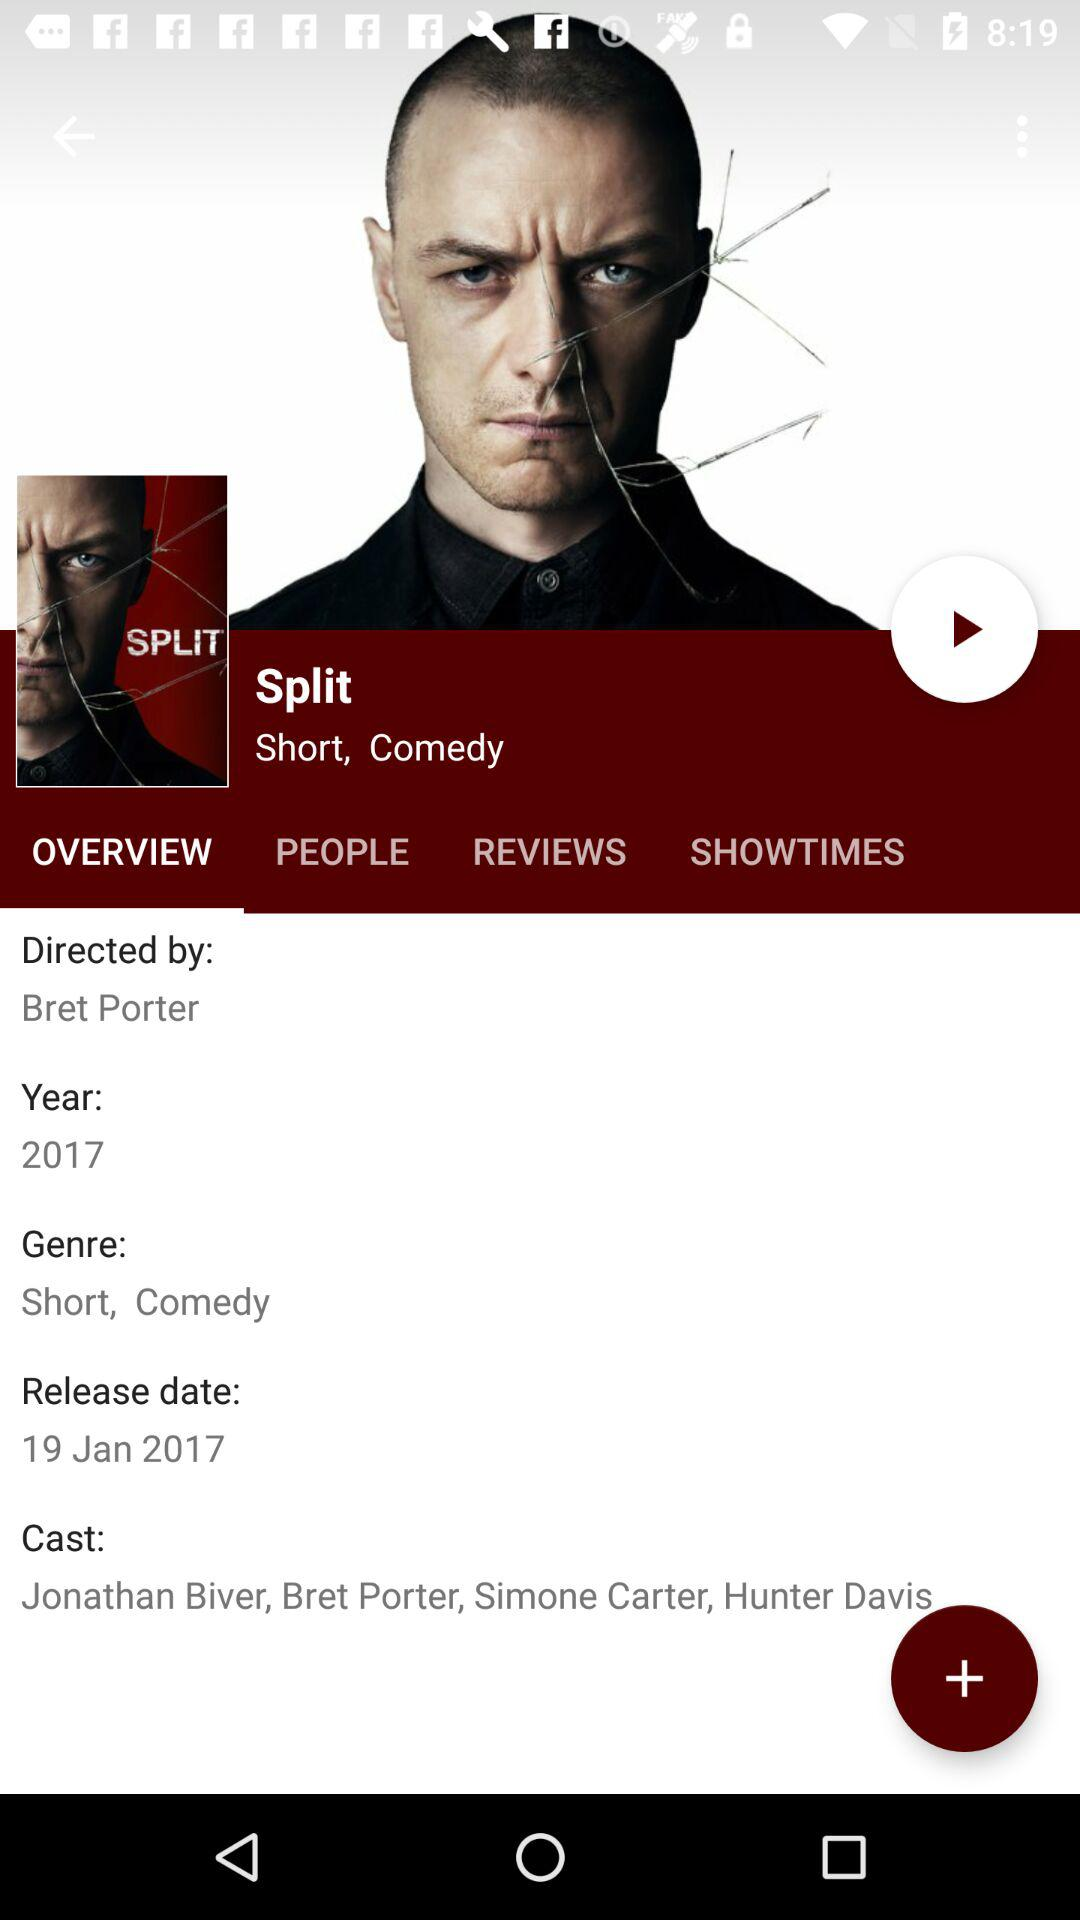Who is the director of the film? The director of the film is "Bret Porter". 